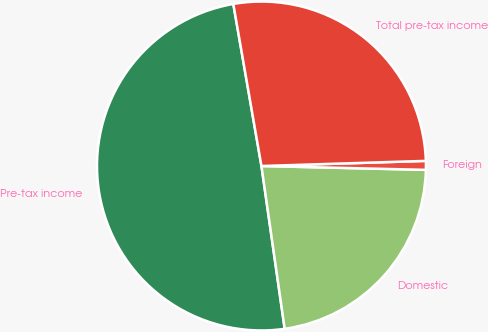Convert chart to OTSL. <chart><loc_0><loc_0><loc_500><loc_500><pie_chart><fcel>Pre-tax income<fcel>Domestic<fcel>Foreign<fcel>Total pre-tax income<nl><fcel>49.52%<fcel>22.37%<fcel>0.87%<fcel>27.24%<nl></chart> 